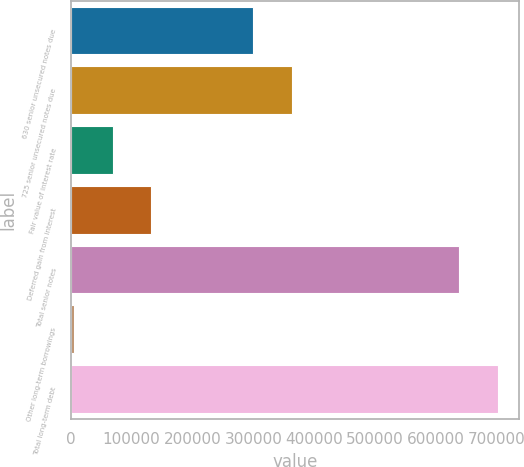Convert chart. <chart><loc_0><loc_0><loc_500><loc_500><bar_chart><fcel>630 senior unsecured notes due<fcel>725 senior unsecured notes due<fcel>Fair value of interest rate<fcel>Deferred gain from interest<fcel>Total senior notes<fcel>Other long-term borrowings<fcel>Total long-term debt<nl><fcel>299162<fcel>362934<fcel>68694.5<fcel>132466<fcel>637715<fcel>4923<fcel>701486<nl></chart> 